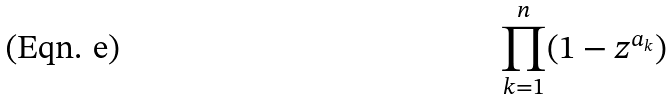Convert formula to latex. <formula><loc_0><loc_0><loc_500><loc_500>\prod _ { k = 1 } ^ { n } ( 1 - z ^ { a _ { k } } )</formula> 